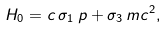<formula> <loc_0><loc_0><loc_500><loc_500>H _ { 0 } = c \, \sigma _ { 1 } \, p + \sigma _ { 3 } \, m c ^ { 2 } ,</formula> 